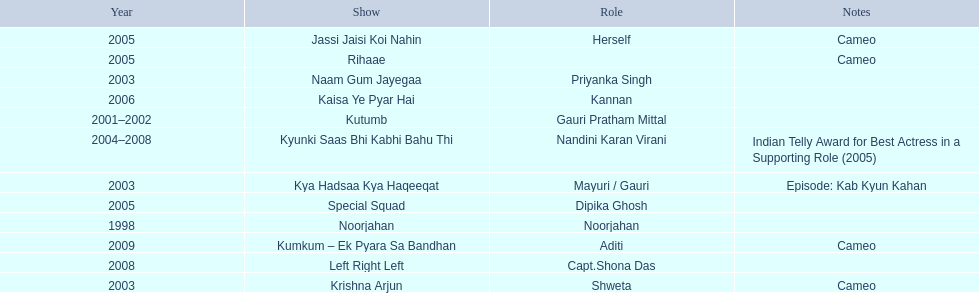Which was the only television show gauri starred in, in which she played herself? Jassi Jaisi Koi Nahin. 